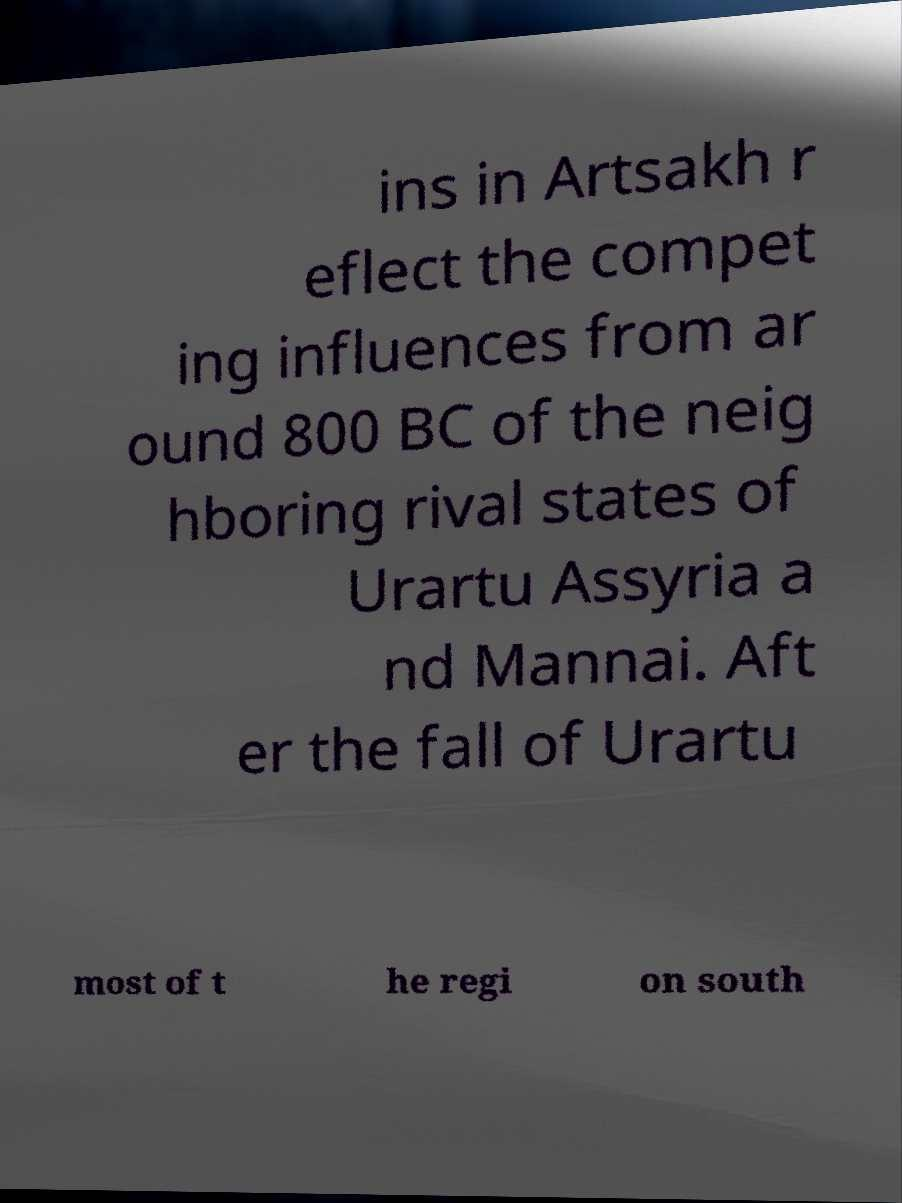Could you assist in decoding the text presented in this image and type it out clearly? ins in Artsakh r eflect the compet ing influences from ar ound 800 BC of the neig hboring rival states of Urartu Assyria a nd Mannai. Aft er the fall of Urartu most of t he regi on south 